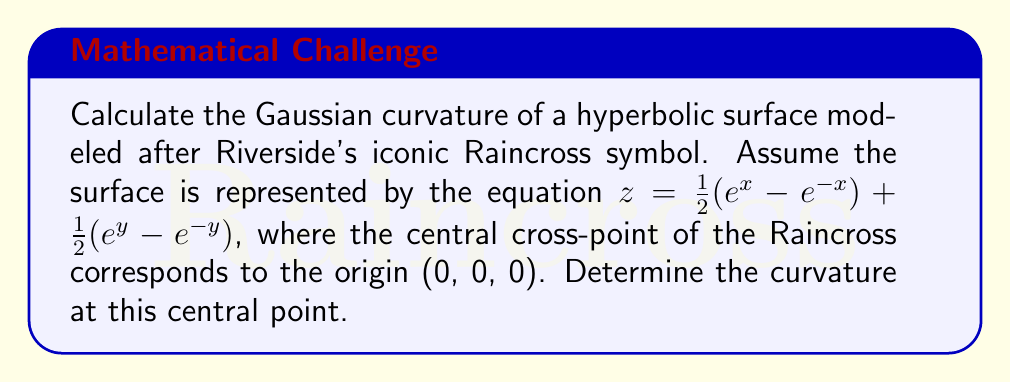Show me your answer to this math problem. To calculate the Gaussian curvature of the hyperbolic surface, we'll follow these steps:

1. The Gaussian curvature K is given by:
   $$K = \frac{LN - M^2}{EG - F^2}$$
   where L, M, N are coefficients of the second fundamental form, and E, F, G are coefficients of the first fundamental form.

2. First, let's calculate the partial derivatives:
   $$z_x = \frac{1}{2}(e^x + e^{-x})$$
   $$z_y = \frac{1}{2}(e^y + e^{-y})$$
   $$z_{xx} = \frac{1}{2}(e^x - e^{-x})$$
   $$z_{yy} = \frac{1}{2}(e^y - e^{-y})$$
   $$z_{xy} = 0$$

3. Now, we can calculate E, F, and G:
   $$E = 1 + z_x^2 = 1 + \frac{1}{4}(e^x + e^{-x})^2$$
   $$F = z_x z_y = \frac{1}{4}(e^x + e^{-x})(e^y + e^{-y})$$
   $$G = 1 + z_y^2 = 1 + \frac{1}{4}(e^y + e^{-y})^2$$

4. Next, we calculate L, M, and N:
   $$L = \frac{z_{xx}}{\sqrt{1 + z_x^2 + z_y^2}} = \frac{\frac{1}{2}(e^x - e^{-x})}{\sqrt{1 + \frac{1}{4}(e^x + e^{-x})^2 + \frac{1}{4}(e^y + e^{-y})^2}}$$
   $$M = \frac{z_{xy}}{\sqrt{1 + z_x^2 + z_y^2}} = 0$$
   $$N = \frac{z_{yy}}{\sqrt{1 + z_x^2 + z_y^2}} = \frac{\frac{1}{2}(e^y - e^{-y})}{\sqrt{1 + \frac{1}{4}(e^x + e^{-x})^2 + \frac{1}{4}(e^y + e^{-y})^2}}$$

5. At the central point (0, 0, 0), we have:
   $$E = G = 2, F = 0$$
   $$L = N = \frac{1}{\sqrt{2}}, M = 0$$

6. Substituting these values into the Gaussian curvature formula:
   $$K = \frac{LN - M^2}{EG - F^2} = \frac{(\frac{1}{\sqrt{2}})(\frac{1}{\sqrt{2}}) - 0^2}{(2)(2) - 0^2} = \frac{1/2}{4} = -\frac{1}{8}$$

The negative value indicates that the surface is hyperbolic at the central point, which aligns with the shape of the Raincross symbol.
Answer: $K = -\frac{1}{8}$ 